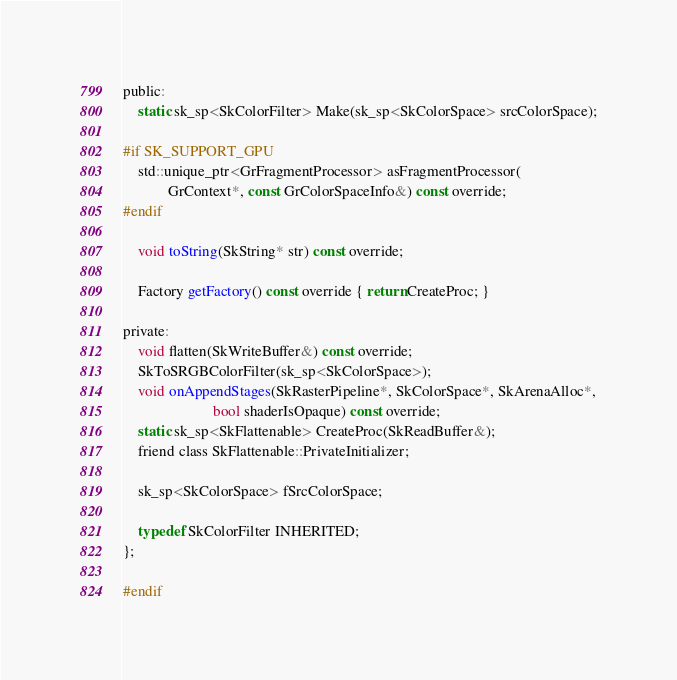<code> <loc_0><loc_0><loc_500><loc_500><_C_>public:
    static sk_sp<SkColorFilter> Make(sk_sp<SkColorSpace> srcColorSpace);

#if SK_SUPPORT_GPU
    std::unique_ptr<GrFragmentProcessor> asFragmentProcessor(
            GrContext*, const GrColorSpaceInfo&) const override;
#endif

    void toString(SkString* str) const override;

    Factory getFactory() const override { return CreateProc; }

private:
    void flatten(SkWriteBuffer&) const override;
    SkToSRGBColorFilter(sk_sp<SkColorSpace>);
    void onAppendStages(SkRasterPipeline*, SkColorSpace*, SkArenaAlloc*,
                        bool shaderIsOpaque) const override;
    static sk_sp<SkFlattenable> CreateProc(SkReadBuffer&);
    friend class SkFlattenable::PrivateInitializer;

    sk_sp<SkColorSpace> fSrcColorSpace;

    typedef SkColorFilter INHERITED;
};

#endif
</code> 